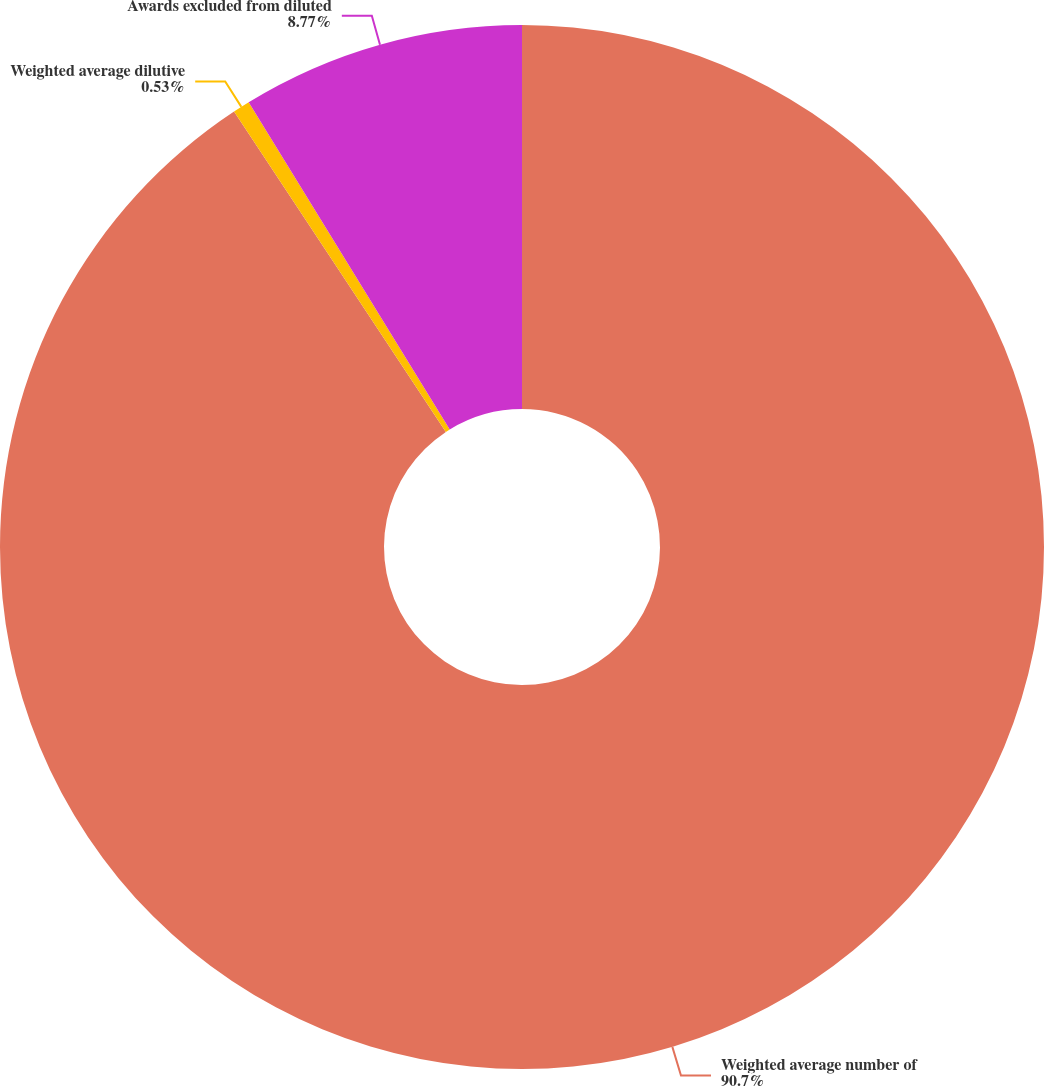Convert chart. <chart><loc_0><loc_0><loc_500><loc_500><pie_chart><fcel>Weighted average number of<fcel>Weighted average dilutive<fcel>Awards excluded from diluted<nl><fcel>90.7%<fcel>0.53%<fcel>8.77%<nl></chart> 